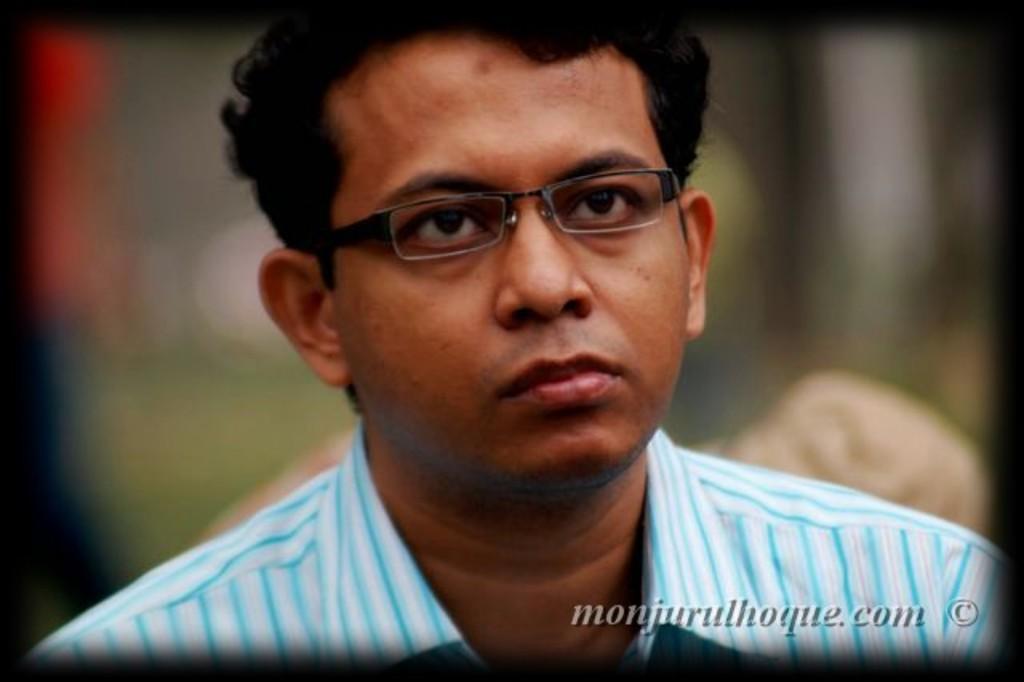Could you give a brief overview of what you see in this image? In this image we can see a person, he is wearing specs, and the background is blurred, and there is a text on the image. 